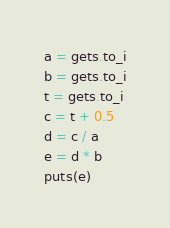Convert code to text. <code><loc_0><loc_0><loc_500><loc_500><_Ruby_>a = gets.to_i
b = gets.to_i
t = gets.to_i
c = t + 0.5
d = c / a
e = d * b
puts(e)</code> 